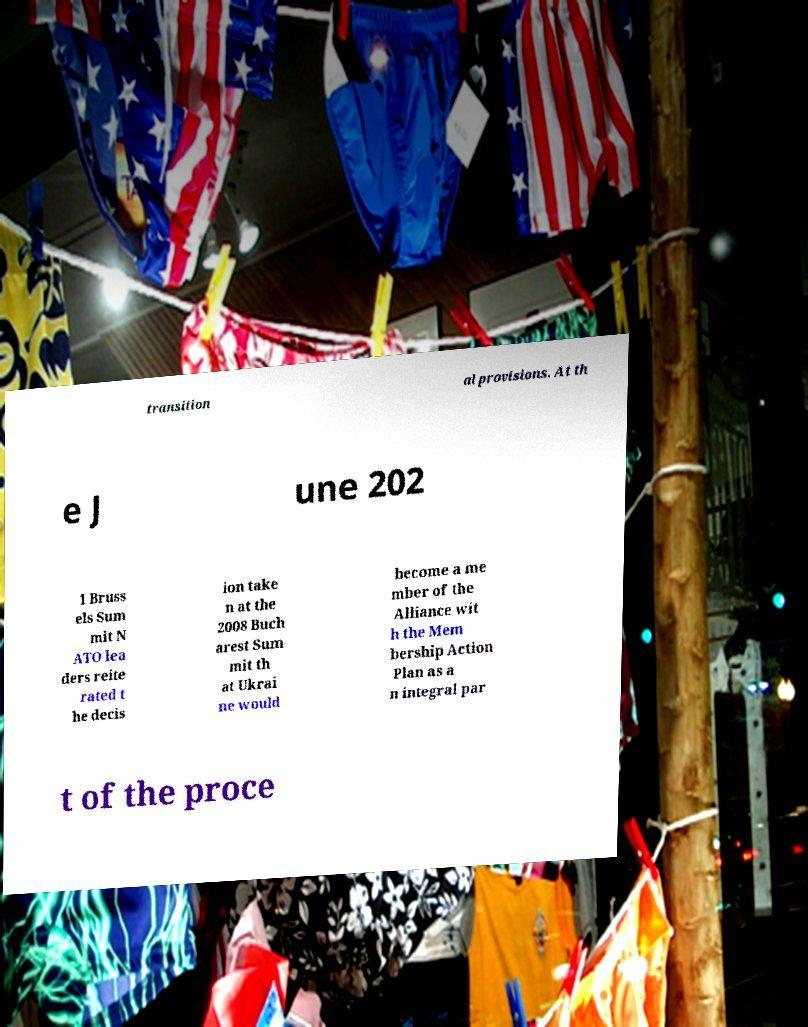There's text embedded in this image that I need extracted. Can you transcribe it verbatim? transition al provisions. At th e J une 202 1 Bruss els Sum mit N ATO lea ders reite rated t he decis ion take n at the 2008 Buch arest Sum mit th at Ukrai ne would become a me mber of the Alliance wit h the Mem bership Action Plan as a n integral par t of the proce 